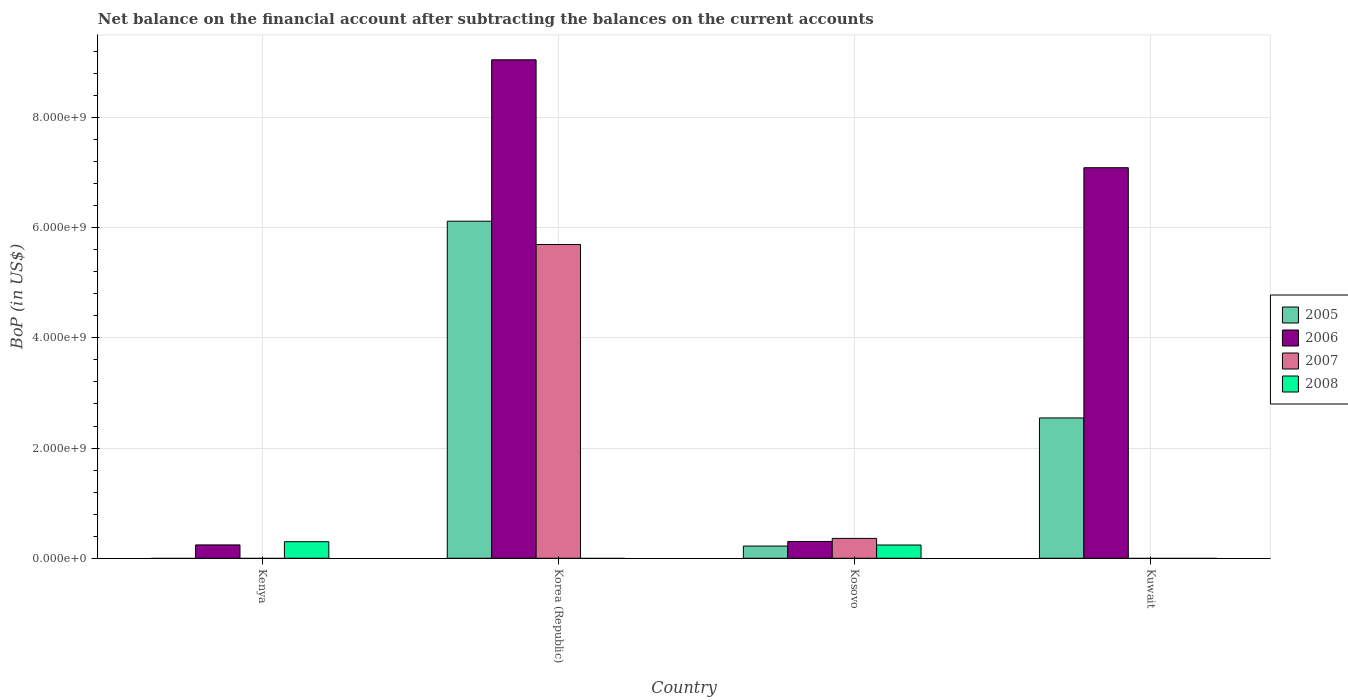How many different coloured bars are there?
Make the answer very short. 4. How many groups of bars are there?
Offer a very short reply. 4. How many bars are there on the 2nd tick from the left?
Ensure brevity in your answer.  3. What is the label of the 3rd group of bars from the left?
Ensure brevity in your answer.  Kosovo. In how many cases, is the number of bars for a given country not equal to the number of legend labels?
Provide a succinct answer. 3. What is the Balance of Payments in 2008 in Kenya?
Give a very brief answer. 3.01e+08. Across all countries, what is the maximum Balance of Payments in 2006?
Provide a succinct answer. 9.05e+09. Across all countries, what is the minimum Balance of Payments in 2006?
Your answer should be compact. 2.42e+08. In which country was the Balance of Payments in 2008 maximum?
Your answer should be very brief. Kenya. What is the total Balance of Payments in 2008 in the graph?
Offer a terse response. 5.41e+08. What is the difference between the Balance of Payments in 2006 in Kenya and that in Korea (Republic)?
Ensure brevity in your answer.  -8.80e+09. What is the difference between the Balance of Payments in 2005 in Korea (Republic) and the Balance of Payments in 2008 in Kuwait?
Make the answer very short. 6.12e+09. What is the average Balance of Payments in 2006 per country?
Give a very brief answer. 4.17e+09. What is the difference between the Balance of Payments of/in 2008 and Balance of Payments of/in 2007 in Kosovo?
Keep it short and to the point. -1.20e+08. What is the ratio of the Balance of Payments in 2007 in Korea (Republic) to that in Kosovo?
Your answer should be very brief. 15.8. What is the difference between the highest and the second highest Balance of Payments in 2006?
Ensure brevity in your answer.  8.74e+09. What is the difference between the highest and the lowest Balance of Payments in 2008?
Your answer should be compact. 3.01e+08. In how many countries, is the Balance of Payments in 2005 greater than the average Balance of Payments in 2005 taken over all countries?
Offer a very short reply. 2. Is the sum of the Balance of Payments in 2005 in Korea (Republic) and Kosovo greater than the maximum Balance of Payments in 2006 across all countries?
Your answer should be compact. No. Is it the case that in every country, the sum of the Balance of Payments in 2008 and Balance of Payments in 2007 is greater than the sum of Balance of Payments in 2006 and Balance of Payments in 2005?
Offer a very short reply. No. Does the graph contain any zero values?
Offer a terse response. Yes. Does the graph contain grids?
Your answer should be compact. Yes. How many legend labels are there?
Ensure brevity in your answer.  4. How are the legend labels stacked?
Provide a short and direct response. Vertical. What is the title of the graph?
Provide a succinct answer. Net balance on the financial account after subtracting the balances on the current accounts. What is the label or title of the Y-axis?
Provide a short and direct response. BoP (in US$). What is the BoP (in US$) of 2005 in Kenya?
Your response must be concise. 0. What is the BoP (in US$) in 2006 in Kenya?
Give a very brief answer. 2.42e+08. What is the BoP (in US$) of 2007 in Kenya?
Keep it short and to the point. 0. What is the BoP (in US$) of 2008 in Kenya?
Keep it short and to the point. 3.01e+08. What is the BoP (in US$) of 2005 in Korea (Republic)?
Provide a short and direct response. 6.12e+09. What is the BoP (in US$) of 2006 in Korea (Republic)?
Offer a terse response. 9.05e+09. What is the BoP (in US$) of 2007 in Korea (Republic)?
Your answer should be compact. 5.69e+09. What is the BoP (in US$) of 2008 in Korea (Republic)?
Offer a terse response. 0. What is the BoP (in US$) in 2005 in Kosovo?
Ensure brevity in your answer.  2.21e+08. What is the BoP (in US$) in 2006 in Kosovo?
Make the answer very short. 3.05e+08. What is the BoP (in US$) in 2007 in Kosovo?
Your response must be concise. 3.60e+08. What is the BoP (in US$) of 2008 in Kosovo?
Keep it short and to the point. 2.41e+08. What is the BoP (in US$) of 2005 in Kuwait?
Provide a short and direct response. 2.55e+09. What is the BoP (in US$) of 2006 in Kuwait?
Offer a very short reply. 7.09e+09. What is the BoP (in US$) of 2008 in Kuwait?
Provide a succinct answer. 0. Across all countries, what is the maximum BoP (in US$) in 2005?
Ensure brevity in your answer.  6.12e+09. Across all countries, what is the maximum BoP (in US$) in 2006?
Keep it short and to the point. 9.05e+09. Across all countries, what is the maximum BoP (in US$) in 2007?
Ensure brevity in your answer.  5.69e+09. Across all countries, what is the maximum BoP (in US$) of 2008?
Provide a succinct answer. 3.01e+08. Across all countries, what is the minimum BoP (in US$) of 2005?
Make the answer very short. 0. Across all countries, what is the minimum BoP (in US$) in 2006?
Provide a succinct answer. 2.42e+08. Across all countries, what is the minimum BoP (in US$) in 2007?
Offer a terse response. 0. Across all countries, what is the minimum BoP (in US$) of 2008?
Provide a short and direct response. 0. What is the total BoP (in US$) of 2005 in the graph?
Keep it short and to the point. 8.88e+09. What is the total BoP (in US$) of 2006 in the graph?
Provide a short and direct response. 1.67e+1. What is the total BoP (in US$) in 2007 in the graph?
Your answer should be compact. 6.05e+09. What is the total BoP (in US$) in 2008 in the graph?
Give a very brief answer. 5.41e+08. What is the difference between the BoP (in US$) of 2006 in Kenya and that in Korea (Republic)?
Offer a very short reply. -8.80e+09. What is the difference between the BoP (in US$) of 2006 in Kenya and that in Kosovo?
Your answer should be very brief. -6.26e+07. What is the difference between the BoP (in US$) of 2008 in Kenya and that in Kosovo?
Provide a short and direct response. 5.99e+07. What is the difference between the BoP (in US$) in 2006 in Kenya and that in Kuwait?
Your response must be concise. -6.84e+09. What is the difference between the BoP (in US$) in 2005 in Korea (Republic) and that in Kosovo?
Your response must be concise. 5.90e+09. What is the difference between the BoP (in US$) in 2006 in Korea (Republic) and that in Kosovo?
Ensure brevity in your answer.  8.74e+09. What is the difference between the BoP (in US$) in 2007 in Korea (Republic) and that in Kosovo?
Ensure brevity in your answer.  5.33e+09. What is the difference between the BoP (in US$) of 2005 in Korea (Republic) and that in Kuwait?
Your response must be concise. 3.57e+09. What is the difference between the BoP (in US$) in 2006 in Korea (Republic) and that in Kuwait?
Provide a short and direct response. 1.96e+09. What is the difference between the BoP (in US$) of 2005 in Kosovo and that in Kuwait?
Offer a very short reply. -2.33e+09. What is the difference between the BoP (in US$) of 2006 in Kosovo and that in Kuwait?
Offer a very short reply. -6.78e+09. What is the difference between the BoP (in US$) of 2006 in Kenya and the BoP (in US$) of 2007 in Korea (Republic)?
Offer a very short reply. -5.45e+09. What is the difference between the BoP (in US$) in 2006 in Kenya and the BoP (in US$) in 2007 in Kosovo?
Your answer should be compact. -1.18e+08. What is the difference between the BoP (in US$) in 2006 in Kenya and the BoP (in US$) in 2008 in Kosovo?
Provide a succinct answer. 1.71e+06. What is the difference between the BoP (in US$) of 2005 in Korea (Republic) and the BoP (in US$) of 2006 in Kosovo?
Your answer should be very brief. 5.81e+09. What is the difference between the BoP (in US$) of 2005 in Korea (Republic) and the BoP (in US$) of 2007 in Kosovo?
Offer a very short reply. 5.76e+09. What is the difference between the BoP (in US$) in 2005 in Korea (Republic) and the BoP (in US$) in 2008 in Kosovo?
Provide a succinct answer. 5.88e+09. What is the difference between the BoP (in US$) in 2006 in Korea (Republic) and the BoP (in US$) in 2007 in Kosovo?
Give a very brief answer. 8.68e+09. What is the difference between the BoP (in US$) of 2006 in Korea (Republic) and the BoP (in US$) of 2008 in Kosovo?
Make the answer very short. 8.80e+09. What is the difference between the BoP (in US$) in 2007 in Korea (Republic) and the BoP (in US$) in 2008 in Kosovo?
Keep it short and to the point. 5.45e+09. What is the difference between the BoP (in US$) in 2005 in Korea (Republic) and the BoP (in US$) in 2006 in Kuwait?
Ensure brevity in your answer.  -9.71e+08. What is the difference between the BoP (in US$) in 2005 in Kosovo and the BoP (in US$) in 2006 in Kuwait?
Your response must be concise. -6.87e+09. What is the average BoP (in US$) of 2005 per country?
Offer a terse response. 2.22e+09. What is the average BoP (in US$) in 2006 per country?
Ensure brevity in your answer.  4.17e+09. What is the average BoP (in US$) of 2007 per country?
Provide a short and direct response. 1.51e+09. What is the average BoP (in US$) of 2008 per country?
Offer a terse response. 1.35e+08. What is the difference between the BoP (in US$) in 2006 and BoP (in US$) in 2008 in Kenya?
Your answer should be compact. -5.82e+07. What is the difference between the BoP (in US$) in 2005 and BoP (in US$) in 2006 in Korea (Republic)?
Offer a very short reply. -2.93e+09. What is the difference between the BoP (in US$) of 2005 and BoP (in US$) of 2007 in Korea (Republic)?
Your answer should be very brief. 4.23e+08. What is the difference between the BoP (in US$) of 2006 and BoP (in US$) of 2007 in Korea (Republic)?
Make the answer very short. 3.35e+09. What is the difference between the BoP (in US$) in 2005 and BoP (in US$) in 2006 in Kosovo?
Provide a short and direct response. -8.37e+07. What is the difference between the BoP (in US$) of 2005 and BoP (in US$) of 2007 in Kosovo?
Provide a succinct answer. -1.39e+08. What is the difference between the BoP (in US$) in 2005 and BoP (in US$) in 2008 in Kosovo?
Offer a terse response. -1.93e+07. What is the difference between the BoP (in US$) in 2006 and BoP (in US$) in 2007 in Kosovo?
Offer a very short reply. -5.55e+07. What is the difference between the BoP (in US$) in 2006 and BoP (in US$) in 2008 in Kosovo?
Offer a very short reply. 6.44e+07. What is the difference between the BoP (in US$) of 2007 and BoP (in US$) of 2008 in Kosovo?
Provide a short and direct response. 1.20e+08. What is the difference between the BoP (in US$) of 2005 and BoP (in US$) of 2006 in Kuwait?
Offer a very short reply. -4.54e+09. What is the ratio of the BoP (in US$) in 2006 in Kenya to that in Korea (Republic)?
Make the answer very short. 0.03. What is the ratio of the BoP (in US$) of 2006 in Kenya to that in Kosovo?
Your response must be concise. 0.79. What is the ratio of the BoP (in US$) in 2008 in Kenya to that in Kosovo?
Provide a succinct answer. 1.25. What is the ratio of the BoP (in US$) in 2006 in Kenya to that in Kuwait?
Make the answer very short. 0.03. What is the ratio of the BoP (in US$) of 2005 in Korea (Republic) to that in Kosovo?
Your response must be concise. 27.65. What is the ratio of the BoP (in US$) of 2006 in Korea (Republic) to that in Kosovo?
Ensure brevity in your answer.  29.66. What is the ratio of the BoP (in US$) in 2007 in Korea (Republic) to that in Kosovo?
Offer a very short reply. 15.8. What is the ratio of the BoP (in US$) in 2005 in Korea (Republic) to that in Kuwait?
Offer a terse response. 2.4. What is the ratio of the BoP (in US$) of 2006 in Korea (Republic) to that in Kuwait?
Keep it short and to the point. 1.28. What is the ratio of the BoP (in US$) in 2005 in Kosovo to that in Kuwait?
Give a very brief answer. 0.09. What is the ratio of the BoP (in US$) in 2006 in Kosovo to that in Kuwait?
Keep it short and to the point. 0.04. What is the difference between the highest and the second highest BoP (in US$) of 2005?
Your answer should be compact. 3.57e+09. What is the difference between the highest and the second highest BoP (in US$) of 2006?
Provide a short and direct response. 1.96e+09. What is the difference between the highest and the lowest BoP (in US$) in 2005?
Ensure brevity in your answer.  6.12e+09. What is the difference between the highest and the lowest BoP (in US$) in 2006?
Give a very brief answer. 8.80e+09. What is the difference between the highest and the lowest BoP (in US$) in 2007?
Provide a short and direct response. 5.69e+09. What is the difference between the highest and the lowest BoP (in US$) of 2008?
Give a very brief answer. 3.01e+08. 